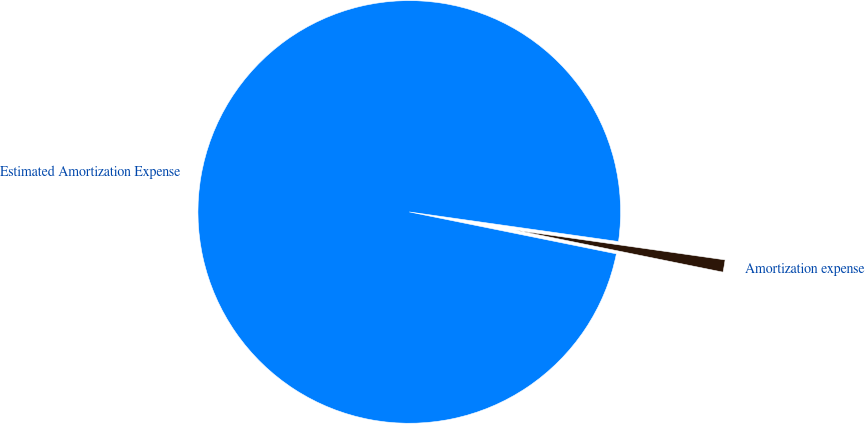Convert chart to OTSL. <chart><loc_0><loc_0><loc_500><loc_500><pie_chart><fcel>Estimated Amortization Expense<fcel>Amortization expense<nl><fcel>99.06%<fcel>0.94%<nl></chart> 